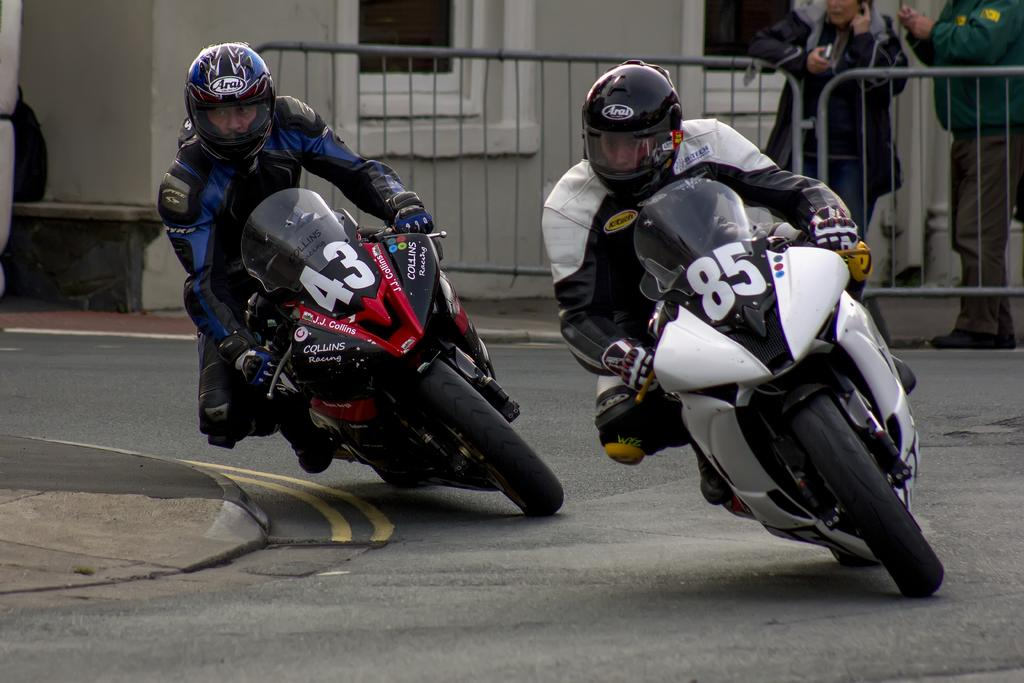What activity are the two persons in the image engaged in? The two persons are participating in a bike race. How are the persons involved in the race? They are riding bikes. Are there any other people visible in the image? Yes, there are two persons standing on the top right side of the image. What type of tray is being used by the person riding the bike? There is no tray present in the image; the persons are riding bikes in a race. Can you describe the cushion that the person standing on the top right side of the image is sitting on? There is no cushion visible in the image; only the two persons standing are mentioned. 